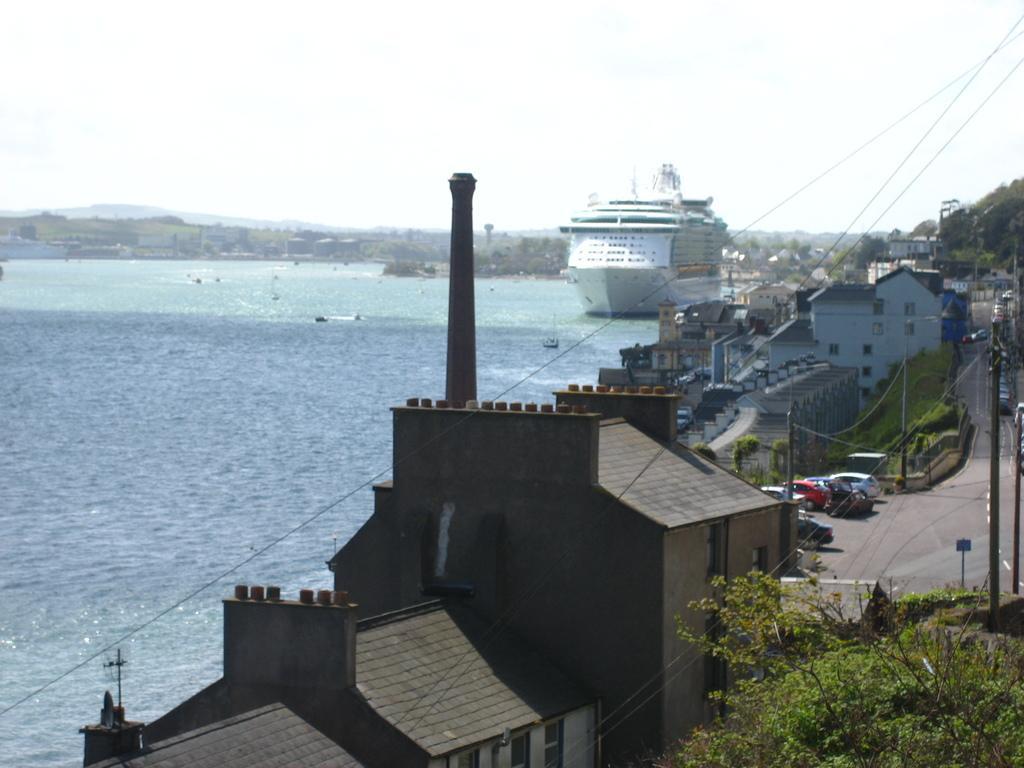Could you give a brief overview of what you see in this image? In this image I can see few buildings,windows,trees,current-poles,wires,sign boards and few vehicles on the road. I can see a white ship and water. The sky is in white color. 